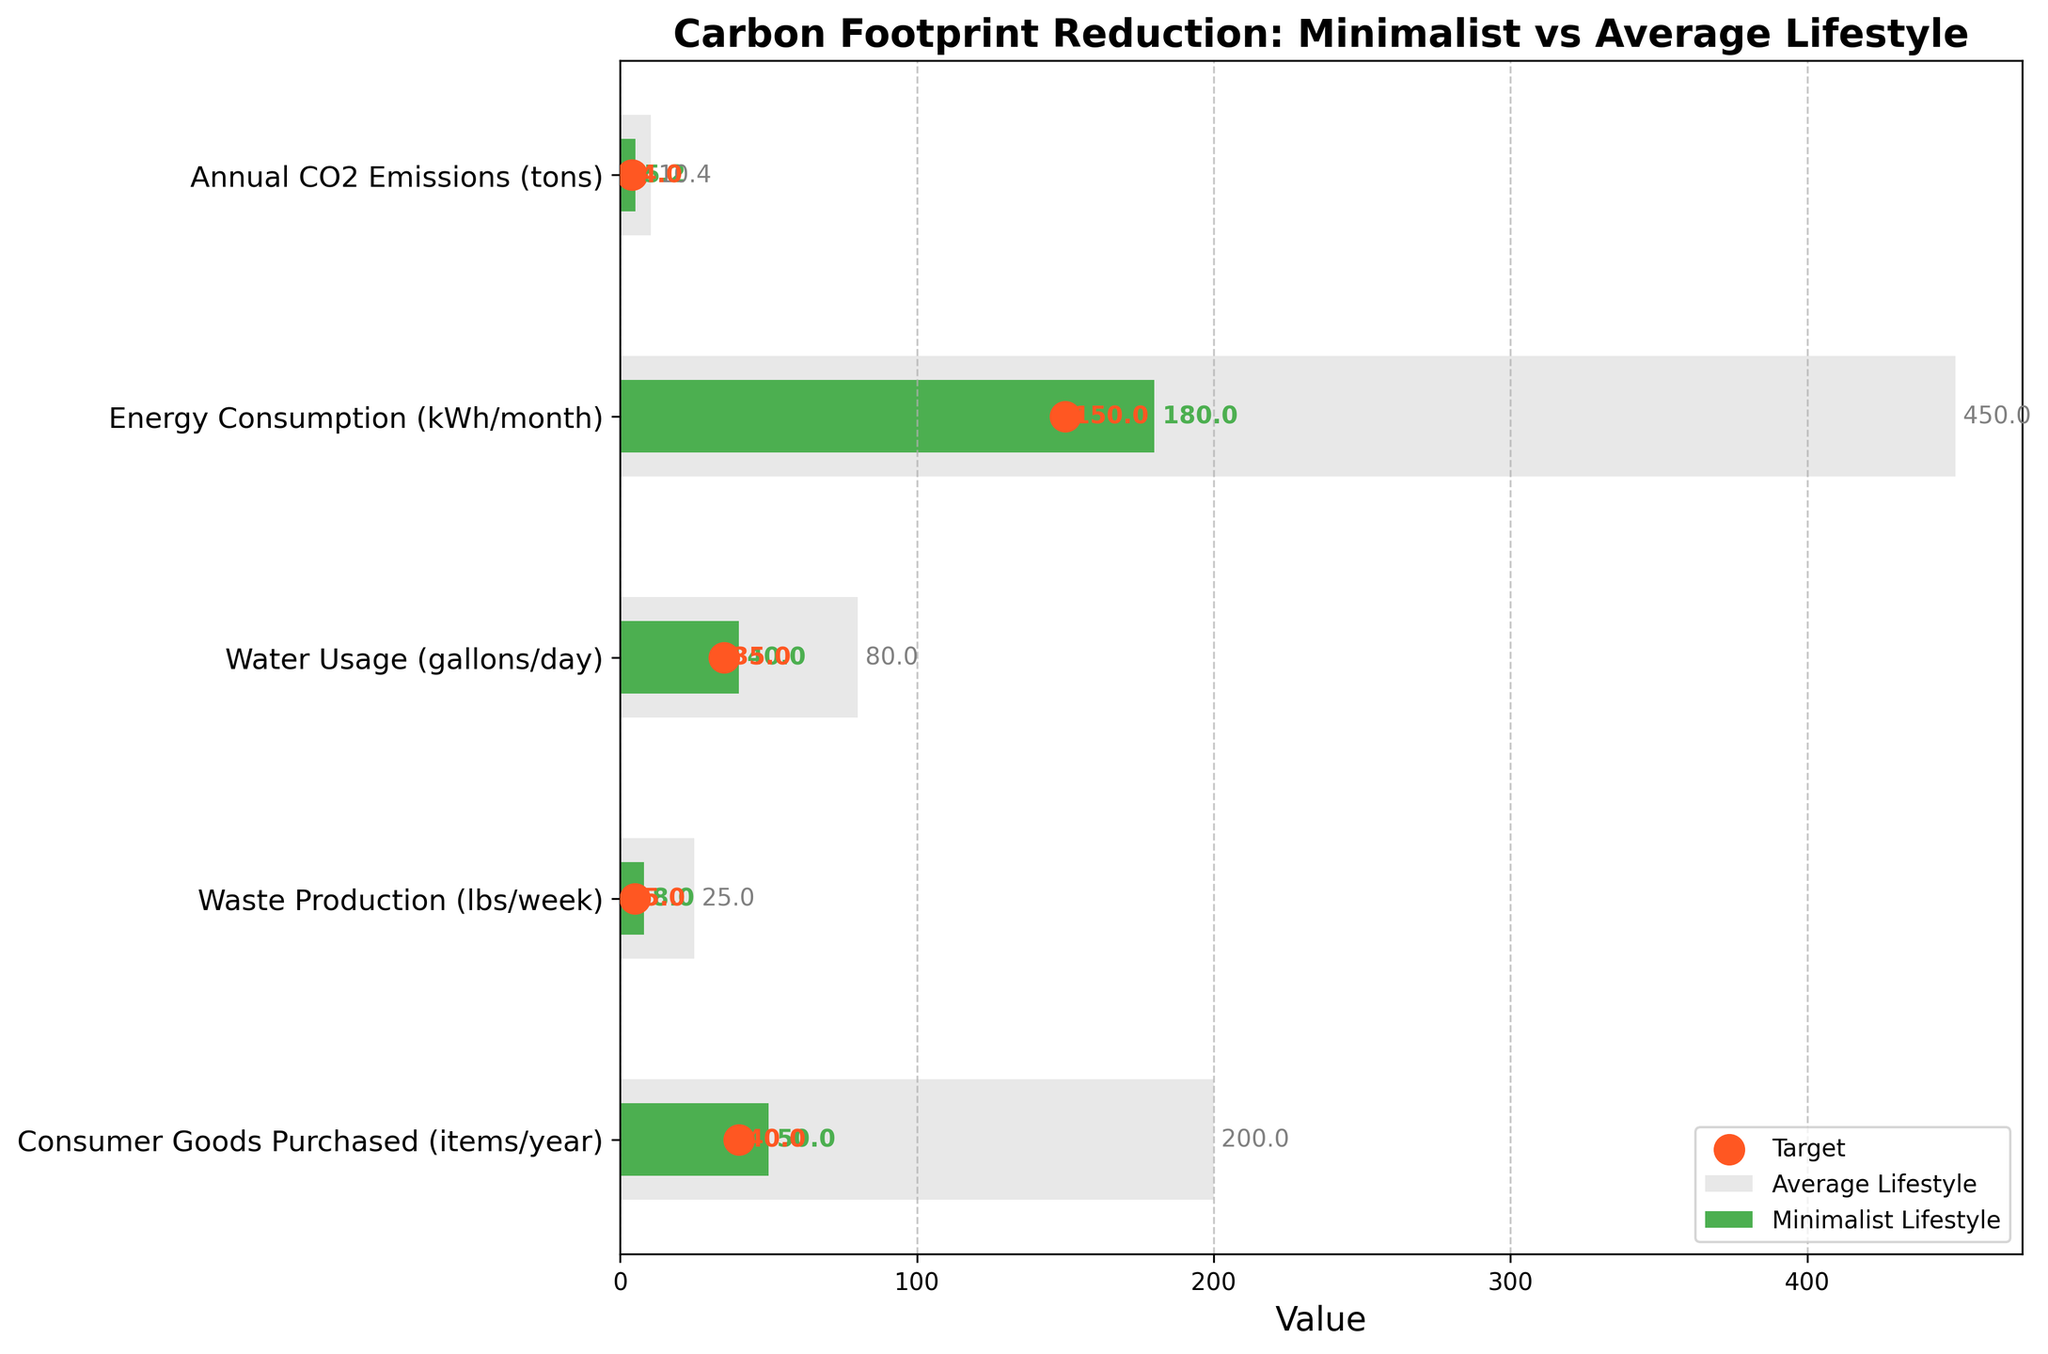what is the title of the figure? The title is usually found at the top of the figure, indicating what the figure is about to provide an overview of the information being presented
Answer: Carbon Footprint Reduction: Minimalist vs Average Lifestyle How many different categories are compared in the figure? Count the number of distinct categories listed along the y-axis
Answer: 5 Which lifestyle uses more water per day, and by how much? Compare the Actual value for the minimalist lifestyle and the Comparative value for the average lifestyle under the "Water Usage (gallons/day)" category
Answer: Average lifestyle uses 40 more gallons per day What is the target value for energy consumption per month? Locate the target indicator (marked in orange) under "Energy Consumption (kWh/month)"
Answer: 150 kWh/month How does the waste production of a minimalist lifestyle compare to its target? Subtract the Actual value for waste production from the Target value to determine how far the minimalist lifestyle is from the target
Answer: 3 lbs/week more than target Which category shows the least difference between the actual and target values for the minimalist lifestyle? Calculate the absolute difference between the Actual and Target values for all categories and find the smallest difference
Answer: Water Usage (-5 gallons/day) What is the difference in consumer goods purchased between the minimalist and average lifestyles? Subtract the Actual value for the minimalist lifestyle from the Comparative value for the average lifestyle in the "Consumer Goods Purchased (items/year)" category
Answer: 150 items/year Which category achieves the target value closest to its actual minimalist value? Identify which category has the target value closest to the actual minimalist value by comparing each category's Actual and Target values
Answer: Consumer Goods Purchased (50 actual vs 40 target) In which category is the reduction in consumption most significant when living a minimalist lifestyle compared to an average lifestyle? Calculate the reduction for each category by subtracting the Actual values from the Comparative values. Find the highest value
Answer: Waste Production (17 lbs/week) 